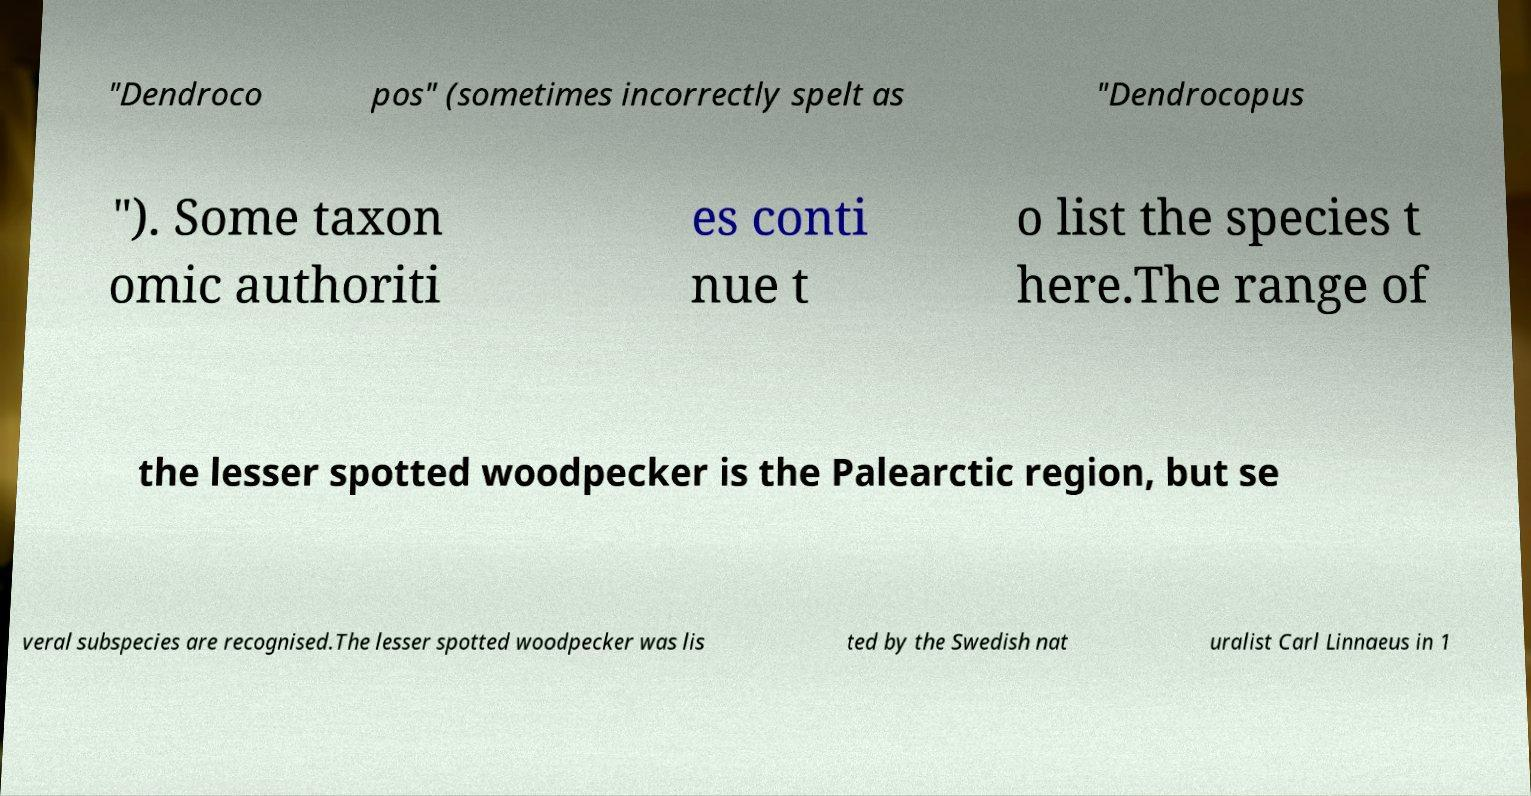Please read and relay the text visible in this image. What does it say? "Dendroco pos" (sometimes incorrectly spelt as "Dendrocopus "). Some taxon omic authoriti es conti nue t o list the species t here.The range of the lesser spotted woodpecker is the Palearctic region, but se veral subspecies are recognised.The lesser spotted woodpecker was lis ted by the Swedish nat uralist Carl Linnaeus in 1 